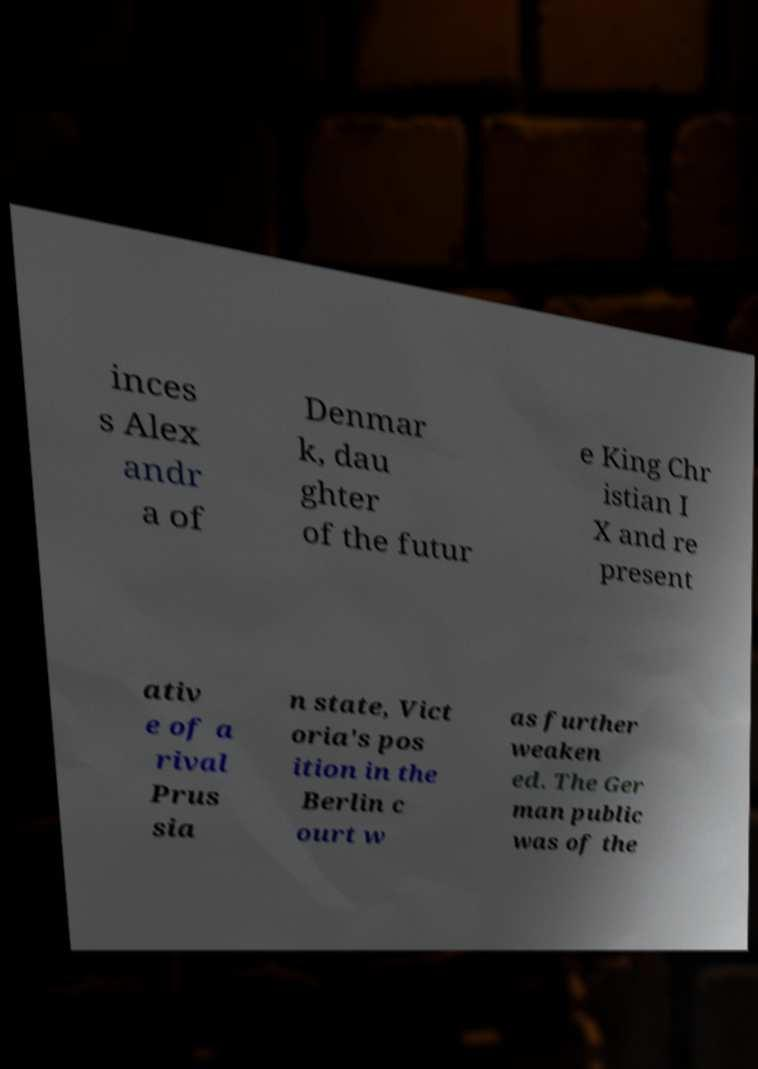What messages or text are displayed in this image? I need them in a readable, typed format. inces s Alex andr a of Denmar k, dau ghter of the futur e King Chr istian I X and re present ativ e of a rival Prus sia n state, Vict oria's pos ition in the Berlin c ourt w as further weaken ed. The Ger man public was of the 